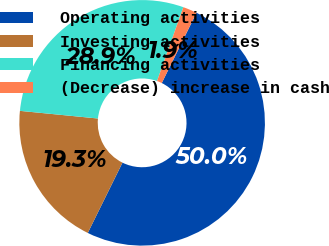<chart> <loc_0><loc_0><loc_500><loc_500><pie_chart><fcel>Operating activities<fcel>Investing activities<fcel>Financing activities<fcel>(Decrease) increase in cash<nl><fcel>50.0%<fcel>19.26%<fcel>28.89%<fcel>1.85%<nl></chart> 